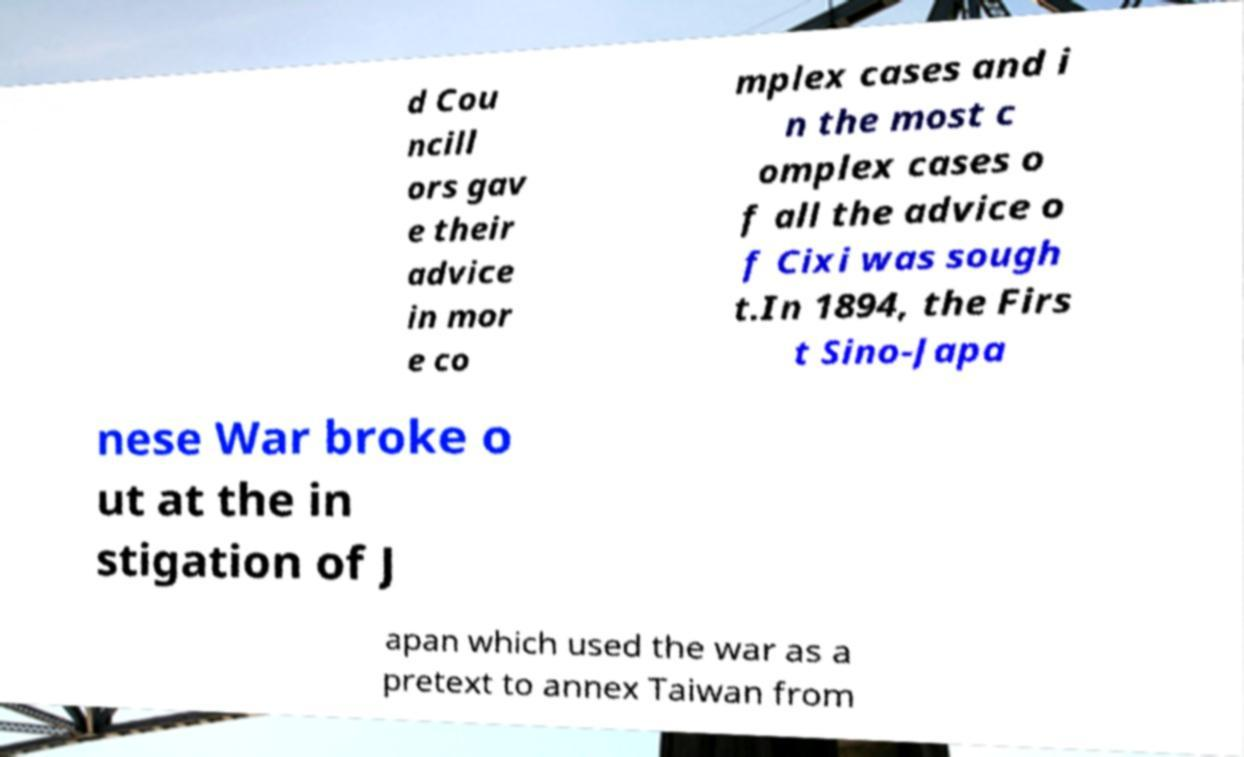Could you assist in decoding the text presented in this image and type it out clearly? d Cou ncill ors gav e their advice in mor e co mplex cases and i n the most c omplex cases o f all the advice o f Cixi was sough t.In 1894, the Firs t Sino-Japa nese War broke o ut at the in stigation of J apan which used the war as a pretext to annex Taiwan from 